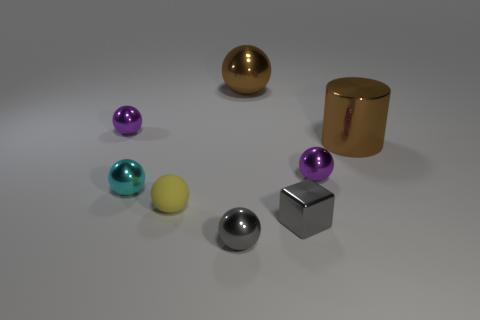Subtract all tiny purple metallic balls. How many balls are left? 4 Subtract all yellow balls. How many balls are left? 5 Subtract all purple spheres. Subtract all blue cubes. How many spheres are left? 4 Subtract all cylinders. How many objects are left? 7 Add 1 tiny metal cylinders. How many objects exist? 9 Subtract 0 brown cubes. How many objects are left? 8 Subtract all big brown objects. Subtract all blue metallic objects. How many objects are left? 6 Add 5 small cyan spheres. How many small cyan spheres are left? 6 Add 3 tiny green things. How many tiny green things exist? 3 